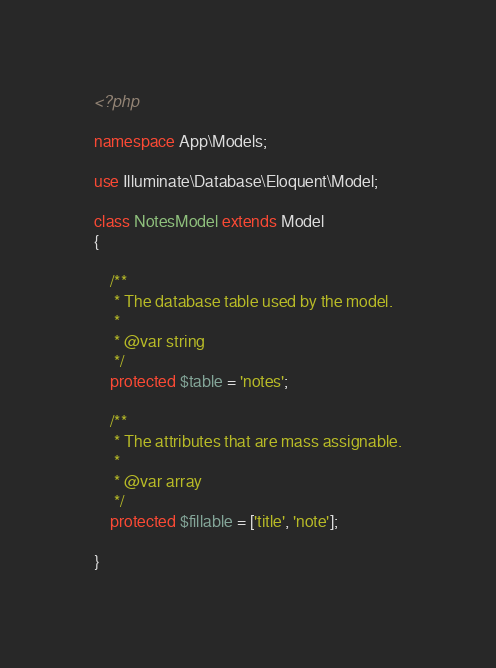<code> <loc_0><loc_0><loc_500><loc_500><_PHP_><?php

namespace App\Models;

use Illuminate\Database\Eloquent\Model;

class NotesModel extends Model
{

    /**
     * The database table used by the model.
     *
     * @var string
     */
    protected $table = 'notes';

    /**
     * The attributes that are mass assignable.
     *
     * @var array
     */
    protected $fillable = ['title', 'note'];

}
</code> 